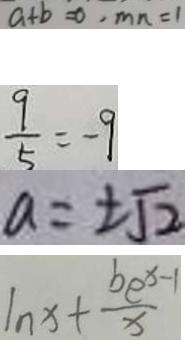<formula> <loc_0><loc_0><loc_500><loc_500>a + b = 0 , m n = 1 
 \frac { 9 } { 5 } = - 9 
 a = \pm \sqrt { 2 } 
 \ln x + \frac { b c ^ { x - 1 } } { x }</formula> 